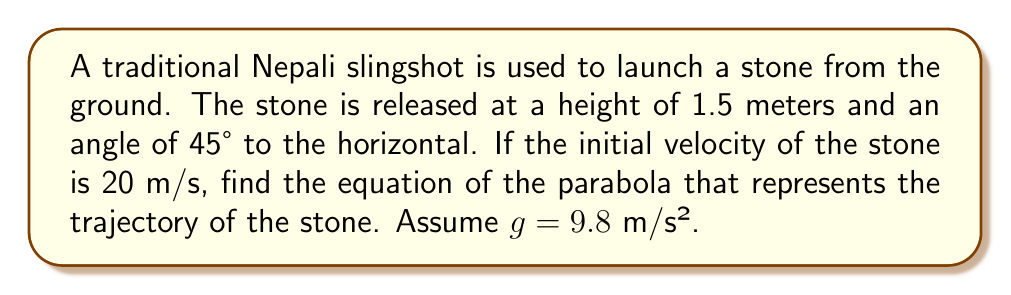Can you solve this math problem? Let's approach this step-by-step:

1) The general equation of a parabola with a vertical axis of symmetry is:
   $$ y = a(x-h)^2 + k $$
   where $(h,k)$ is the vertex of the parabola.

2) In projectile motion, we can use the parametric equations:
   $$ x = v_0 \cos(\theta) \cdot t $$
   $$ y = v_0 \sin(\theta) \cdot t - \frac{1}{2}gt^2 + y_0 $$
   where $v_0$ is the initial velocity, $\theta$ is the launch angle, $t$ is time, and $y_0$ is the initial height.

3) Given:
   $v_0 = 20$ m/s
   $\theta = 45°$
   $y_0 = 1.5$ m
   $g = 9.8$ m/s²

4) Let's eliminate $t$ from the parametric equations:
   $t = \frac{x}{v_0 \cos(\theta)}$

5) Substitute this into the $y$ equation:
   $$ y = v_0 \sin(\theta) \cdot \frac{x}{v_0 \cos(\theta)} - \frac{1}{2}g(\frac{x}{v_0 \cos(\theta)})^2 + y_0 $$

6) Simplify:
   $$ y = x\tan(\theta) - \frac{gx^2}{2(v_0 \cos(\theta))^2} + y_0 $$

7) Substitute the given values:
   $$ y = x\tan(45°) - \frac{9.8x^2}{2(20 \cos(45°))^2} + 1.5 $$

8) Simplify further:
   $$ y = x - 0.0175x^2 + 1.5 $$

9) Rearrange to standard form:
   $$ y = -0.0175x^2 + x + 1.5 $$

This is the equation of the parabola representing the trajectory of the stone.
Answer: $y = -0.0175x^2 + x + 1.5$ 